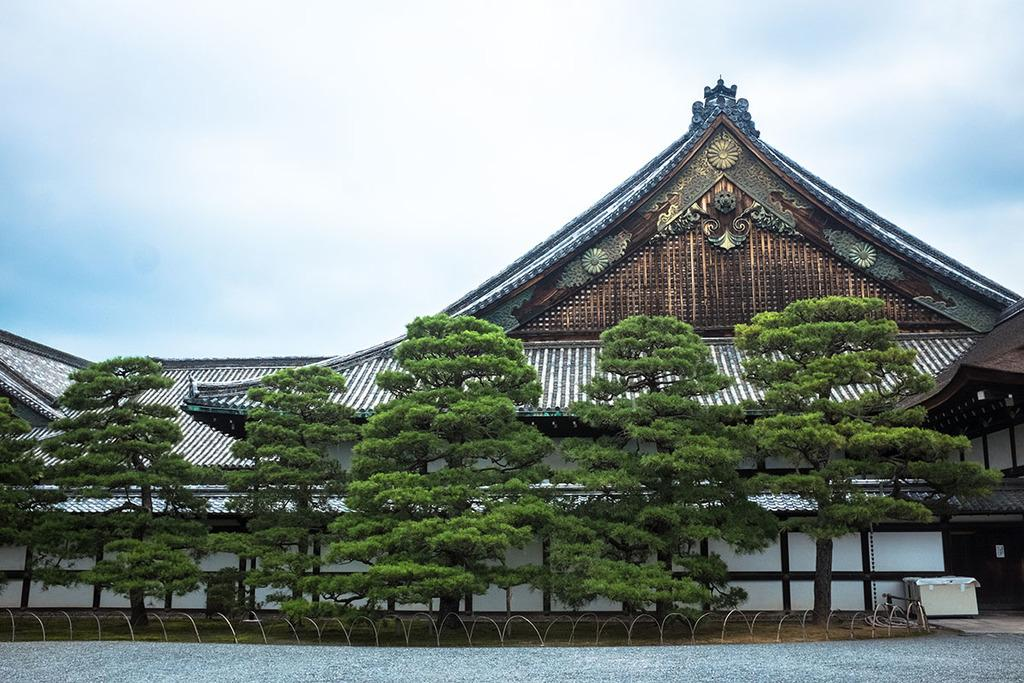Where was the picture taken? The picture was clicked outside. What objects can be seen in the foreground of the image? There are metal rods and a box in the foreground of the image. What type of vegetation is visible in the foreground of the image? There are trees in the foreground of the image. What type of structure is visible in the image? There is a house visible in the image. What part of the natural environment is visible in the background of the image? The sky is visible in the background of the image. How many nails are holding the tray in the image? There is no tray or nails present in the image. What type of animal can be seen grazing near the house in the image? There are no animals visible in the image, including yaks. 